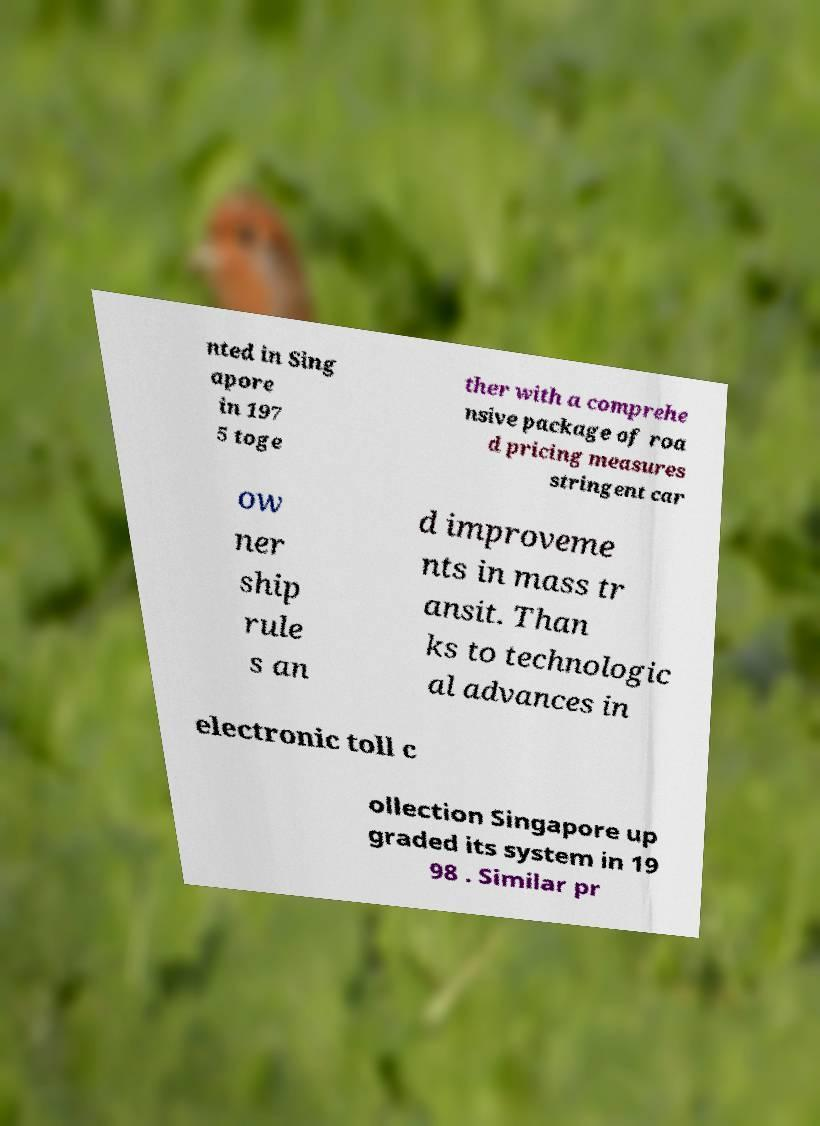What messages or text are displayed in this image? I need them in a readable, typed format. nted in Sing apore in 197 5 toge ther with a comprehe nsive package of roa d pricing measures stringent car ow ner ship rule s an d improveme nts in mass tr ansit. Than ks to technologic al advances in electronic toll c ollection Singapore up graded its system in 19 98 . Similar pr 